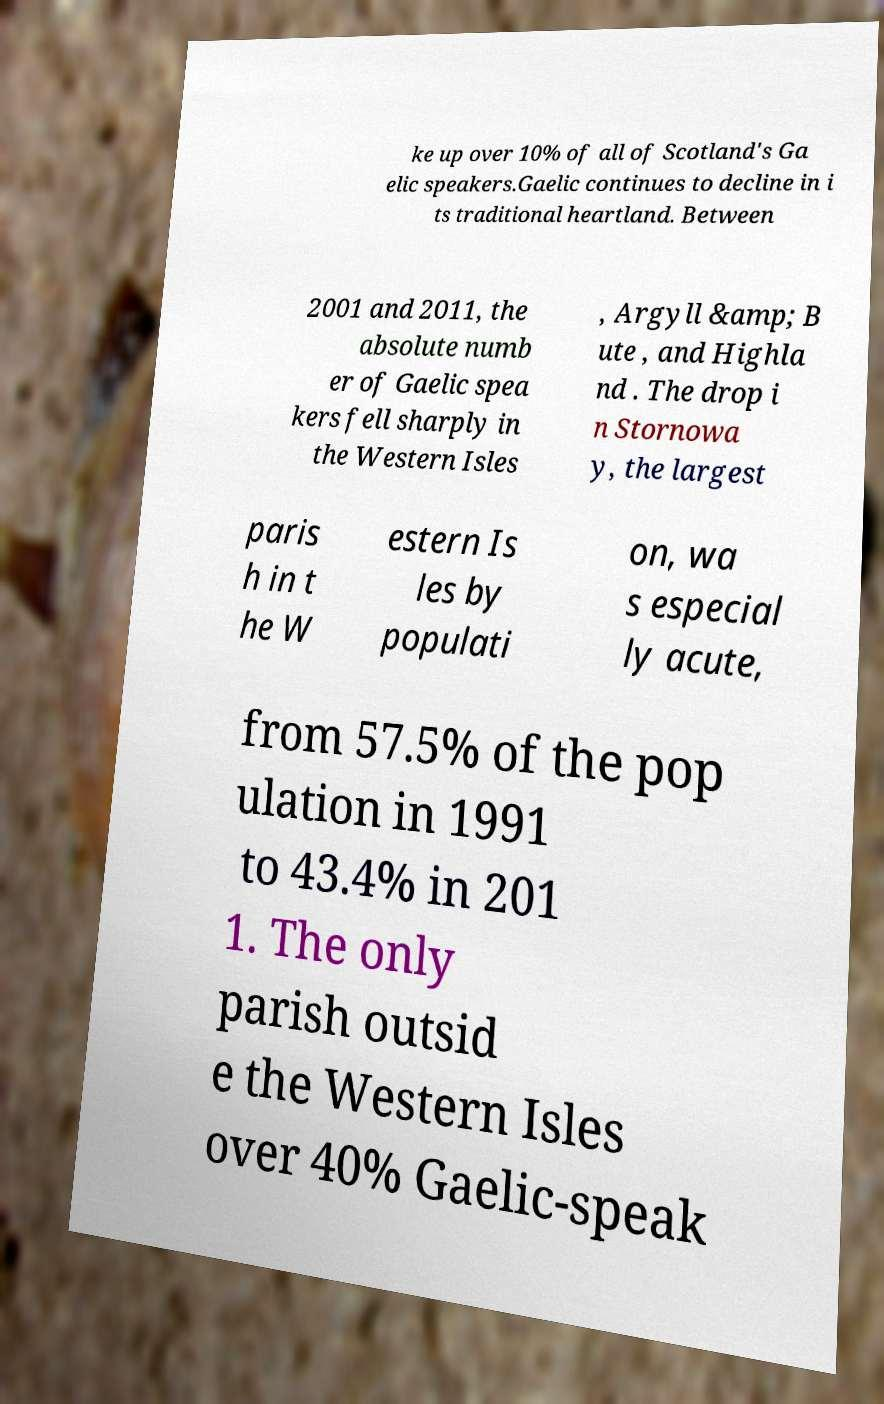Please read and relay the text visible in this image. What does it say? ke up over 10% of all of Scotland's Ga elic speakers.Gaelic continues to decline in i ts traditional heartland. Between 2001 and 2011, the absolute numb er of Gaelic spea kers fell sharply in the Western Isles , Argyll &amp; B ute , and Highla nd . The drop i n Stornowa y, the largest paris h in t he W estern Is les by populati on, wa s especial ly acute, from 57.5% of the pop ulation in 1991 to 43.4% in 201 1. The only parish outsid e the Western Isles over 40% Gaelic-speak 